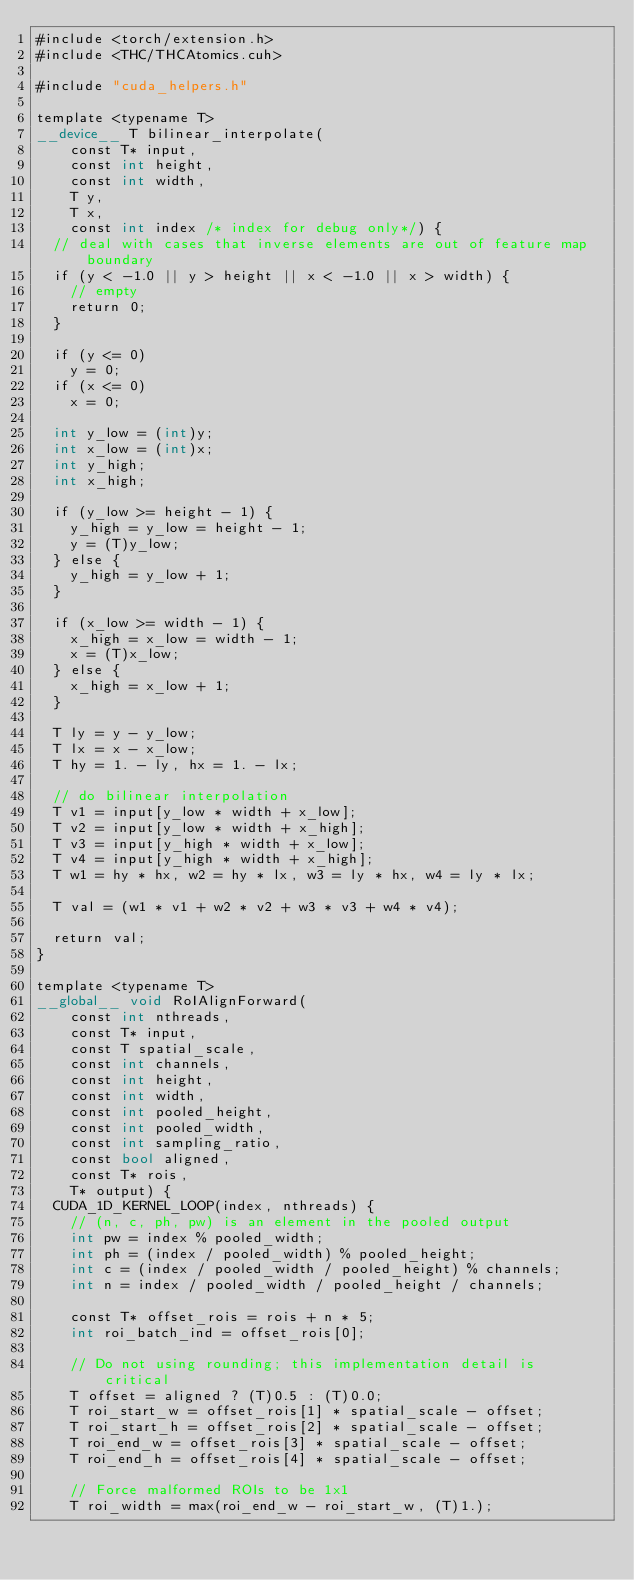Convert code to text. <code><loc_0><loc_0><loc_500><loc_500><_Cuda_>#include <torch/extension.h>
#include <THC/THCAtomics.cuh>

#include "cuda_helpers.h"

template <typename T>
__device__ T bilinear_interpolate(
    const T* input,
    const int height,
    const int width,
    T y,
    T x,
    const int index /* index for debug only*/) {
  // deal with cases that inverse elements are out of feature map boundary
  if (y < -1.0 || y > height || x < -1.0 || x > width) {
    // empty
    return 0;
  }

  if (y <= 0)
    y = 0;
  if (x <= 0)
    x = 0;

  int y_low = (int)y;
  int x_low = (int)x;
  int y_high;
  int x_high;

  if (y_low >= height - 1) {
    y_high = y_low = height - 1;
    y = (T)y_low;
  } else {
    y_high = y_low + 1;
  }

  if (x_low >= width - 1) {
    x_high = x_low = width - 1;
    x = (T)x_low;
  } else {
    x_high = x_low + 1;
  }

  T ly = y - y_low;
  T lx = x - x_low;
  T hy = 1. - ly, hx = 1. - lx;

  // do bilinear interpolation
  T v1 = input[y_low * width + x_low];
  T v2 = input[y_low * width + x_high];
  T v3 = input[y_high * width + x_low];
  T v4 = input[y_high * width + x_high];
  T w1 = hy * hx, w2 = hy * lx, w3 = ly * hx, w4 = ly * lx;

  T val = (w1 * v1 + w2 * v2 + w3 * v3 + w4 * v4);

  return val;
}

template <typename T>
__global__ void RoIAlignForward(
    const int nthreads,
    const T* input,
    const T spatial_scale,
    const int channels,
    const int height,
    const int width,
    const int pooled_height,
    const int pooled_width,
    const int sampling_ratio,
    const bool aligned,
    const T* rois,
    T* output) {
  CUDA_1D_KERNEL_LOOP(index, nthreads) {
    // (n, c, ph, pw) is an element in the pooled output
    int pw = index % pooled_width;
    int ph = (index / pooled_width) % pooled_height;
    int c = (index / pooled_width / pooled_height) % channels;
    int n = index / pooled_width / pooled_height / channels;

    const T* offset_rois = rois + n * 5;
    int roi_batch_ind = offset_rois[0];

    // Do not using rounding; this implementation detail is critical
    T offset = aligned ? (T)0.5 : (T)0.0;
    T roi_start_w = offset_rois[1] * spatial_scale - offset;
    T roi_start_h = offset_rois[2] * spatial_scale - offset;
    T roi_end_w = offset_rois[3] * spatial_scale - offset;
    T roi_end_h = offset_rois[4] * spatial_scale - offset;

    // Force malformed ROIs to be 1x1
    T roi_width = max(roi_end_w - roi_start_w, (T)1.);</code> 